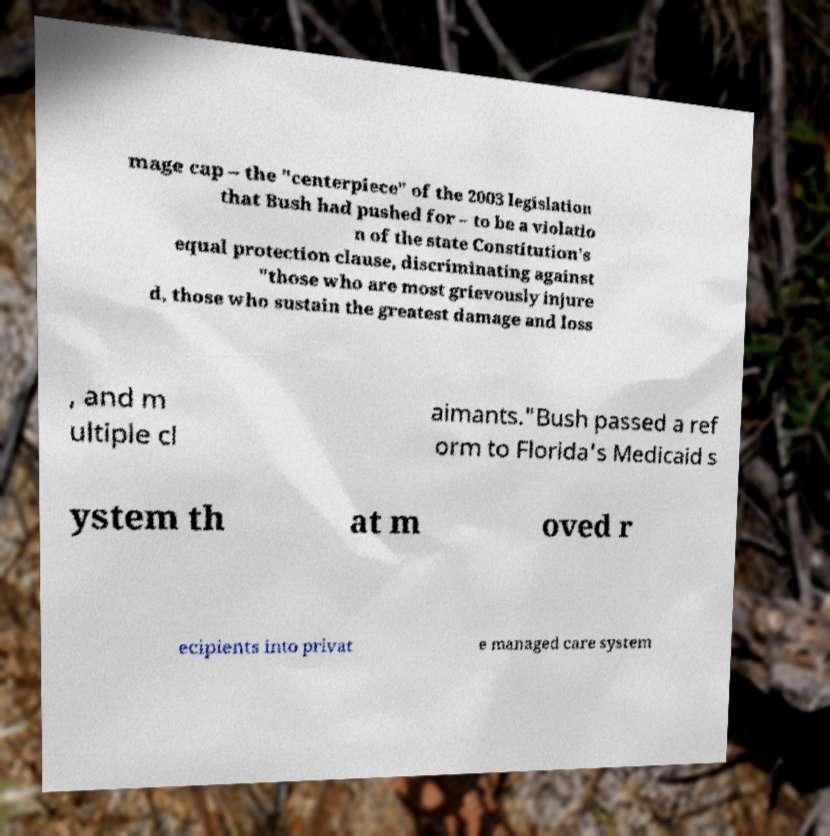I need the written content from this picture converted into text. Can you do that? mage cap – the "centerpiece" of the 2003 legislation that Bush had pushed for – to be a violatio n of the state Constitution's equal protection clause, discriminating against "those who are most grievously injure d, those who sustain the greatest damage and loss , and m ultiple cl aimants."Bush passed a ref orm to Florida's Medicaid s ystem th at m oved r ecipients into privat e managed care system 